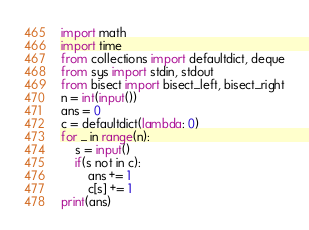Convert code to text. <code><loc_0><loc_0><loc_500><loc_500><_Python_>import math
import time
from collections import defaultdict, deque
from sys import stdin, stdout
from bisect import bisect_left, bisect_right
n = int(input())
ans = 0
c = defaultdict(lambda: 0)
for _ in range(n):
    s = input()
    if(s not in c):
        ans += 1
        c[s] += 1
print(ans)
</code> 